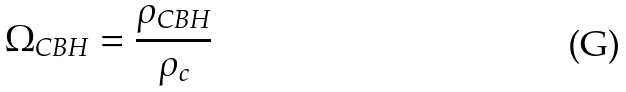Convert formula to latex. <formula><loc_0><loc_0><loc_500><loc_500>\Omega _ { C B H } = \frac { \rho _ { C B H } } { \rho _ { c } }</formula> 